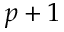Convert formula to latex. <formula><loc_0><loc_0><loc_500><loc_500>p + 1</formula> 